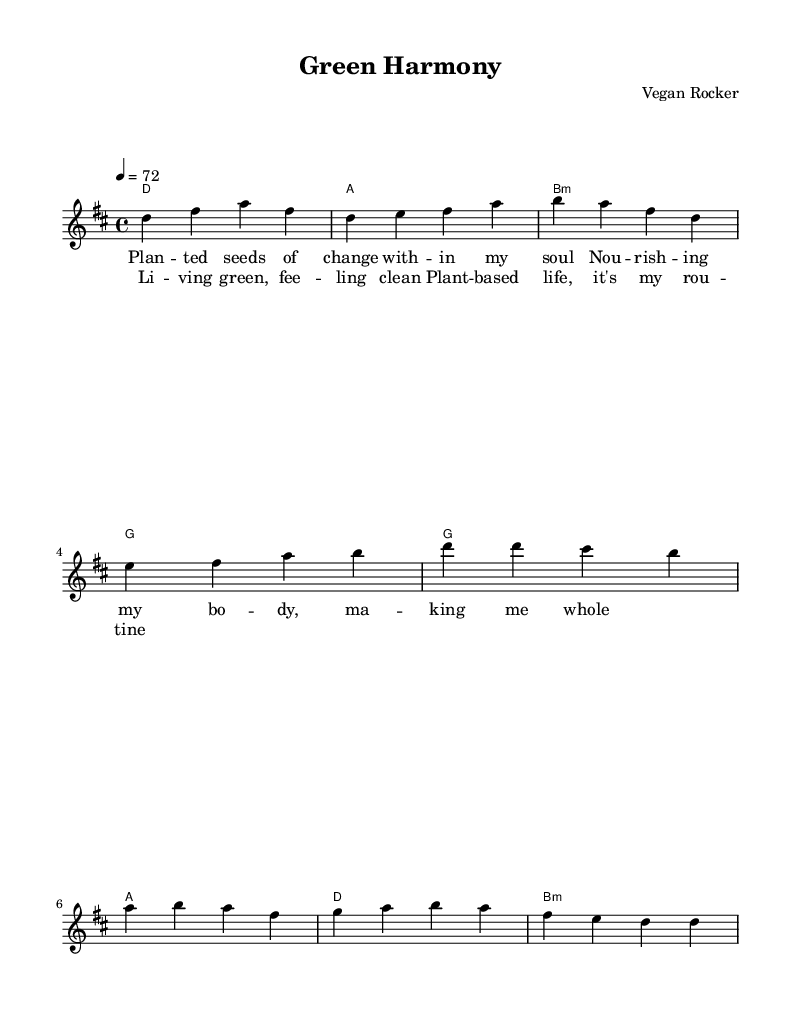What is the key signature of this music? The key signature is D major, which has two sharps (F# and C#). This can be found by looking at the key indicated at the beginning of the score.
Answer: D major What is the time signature of this music? The time signature is 4/4. This is explicitly stated in the notation at the beginning of the score, indicating four beats per measure.
Answer: 4/4 What is the tempo marking for this piece? The tempo marking is 4 = 72, which indicates that the quarter note gets 72 beats per minute. This tempo is found in the header section of the score.
Answer: 72 How many measures are in the verse? There are four measures in the verse section as indicated by the counting of bars in the melody line.
Answer: 4 What chord follows the B minor chord in the verse? The chord that follows the B minor chord in the verse is G major. This can be determined by reviewing the chord sequence listed under harmonies corresponding to the verse melody.
Answer: G Which section contains the lyrics "Living green, feeling clean"? These lyrics are found in the chorus section, as indicated by the provided lyric mode aligned with the melody.
Answer: Chorus What is the structure of the song based on the sections provided? The song structure consists of a verse followed by a chorus, which is a common format in rock music. This can be understood by analyzing the sequence of the musical sections given in the score.
Answer: Verse, Chorus 